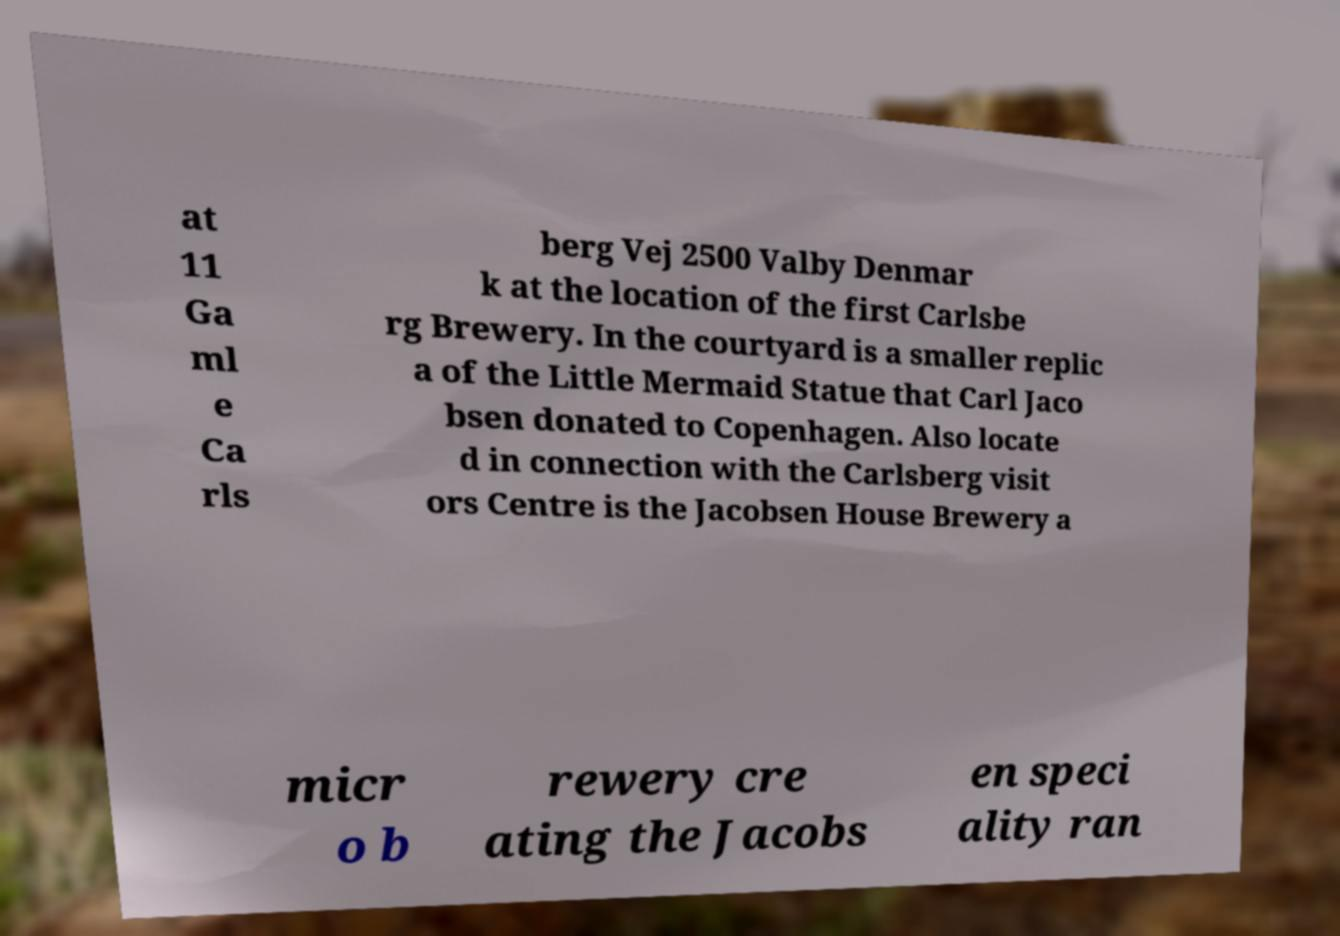Could you extract and type out the text from this image? at 11 Ga ml e Ca rls berg Vej 2500 Valby Denmar k at the location of the first Carlsbe rg Brewery. In the courtyard is a smaller replic a of the Little Mermaid Statue that Carl Jaco bsen donated to Copenhagen. Also locate d in connection with the Carlsberg visit ors Centre is the Jacobsen House Brewery a micr o b rewery cre ating the Jacobs en speci ality ran 